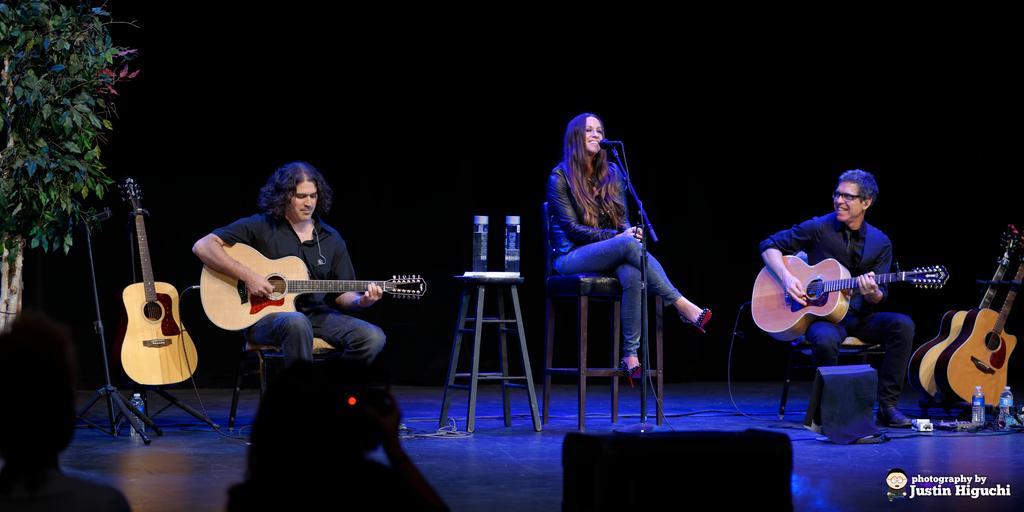Please provide a concise description of this image. In this image, There are some people sitting and they are holding some music instruments , In the middle there is a woman singing in the microphone, In the left side there is a green color plant. 